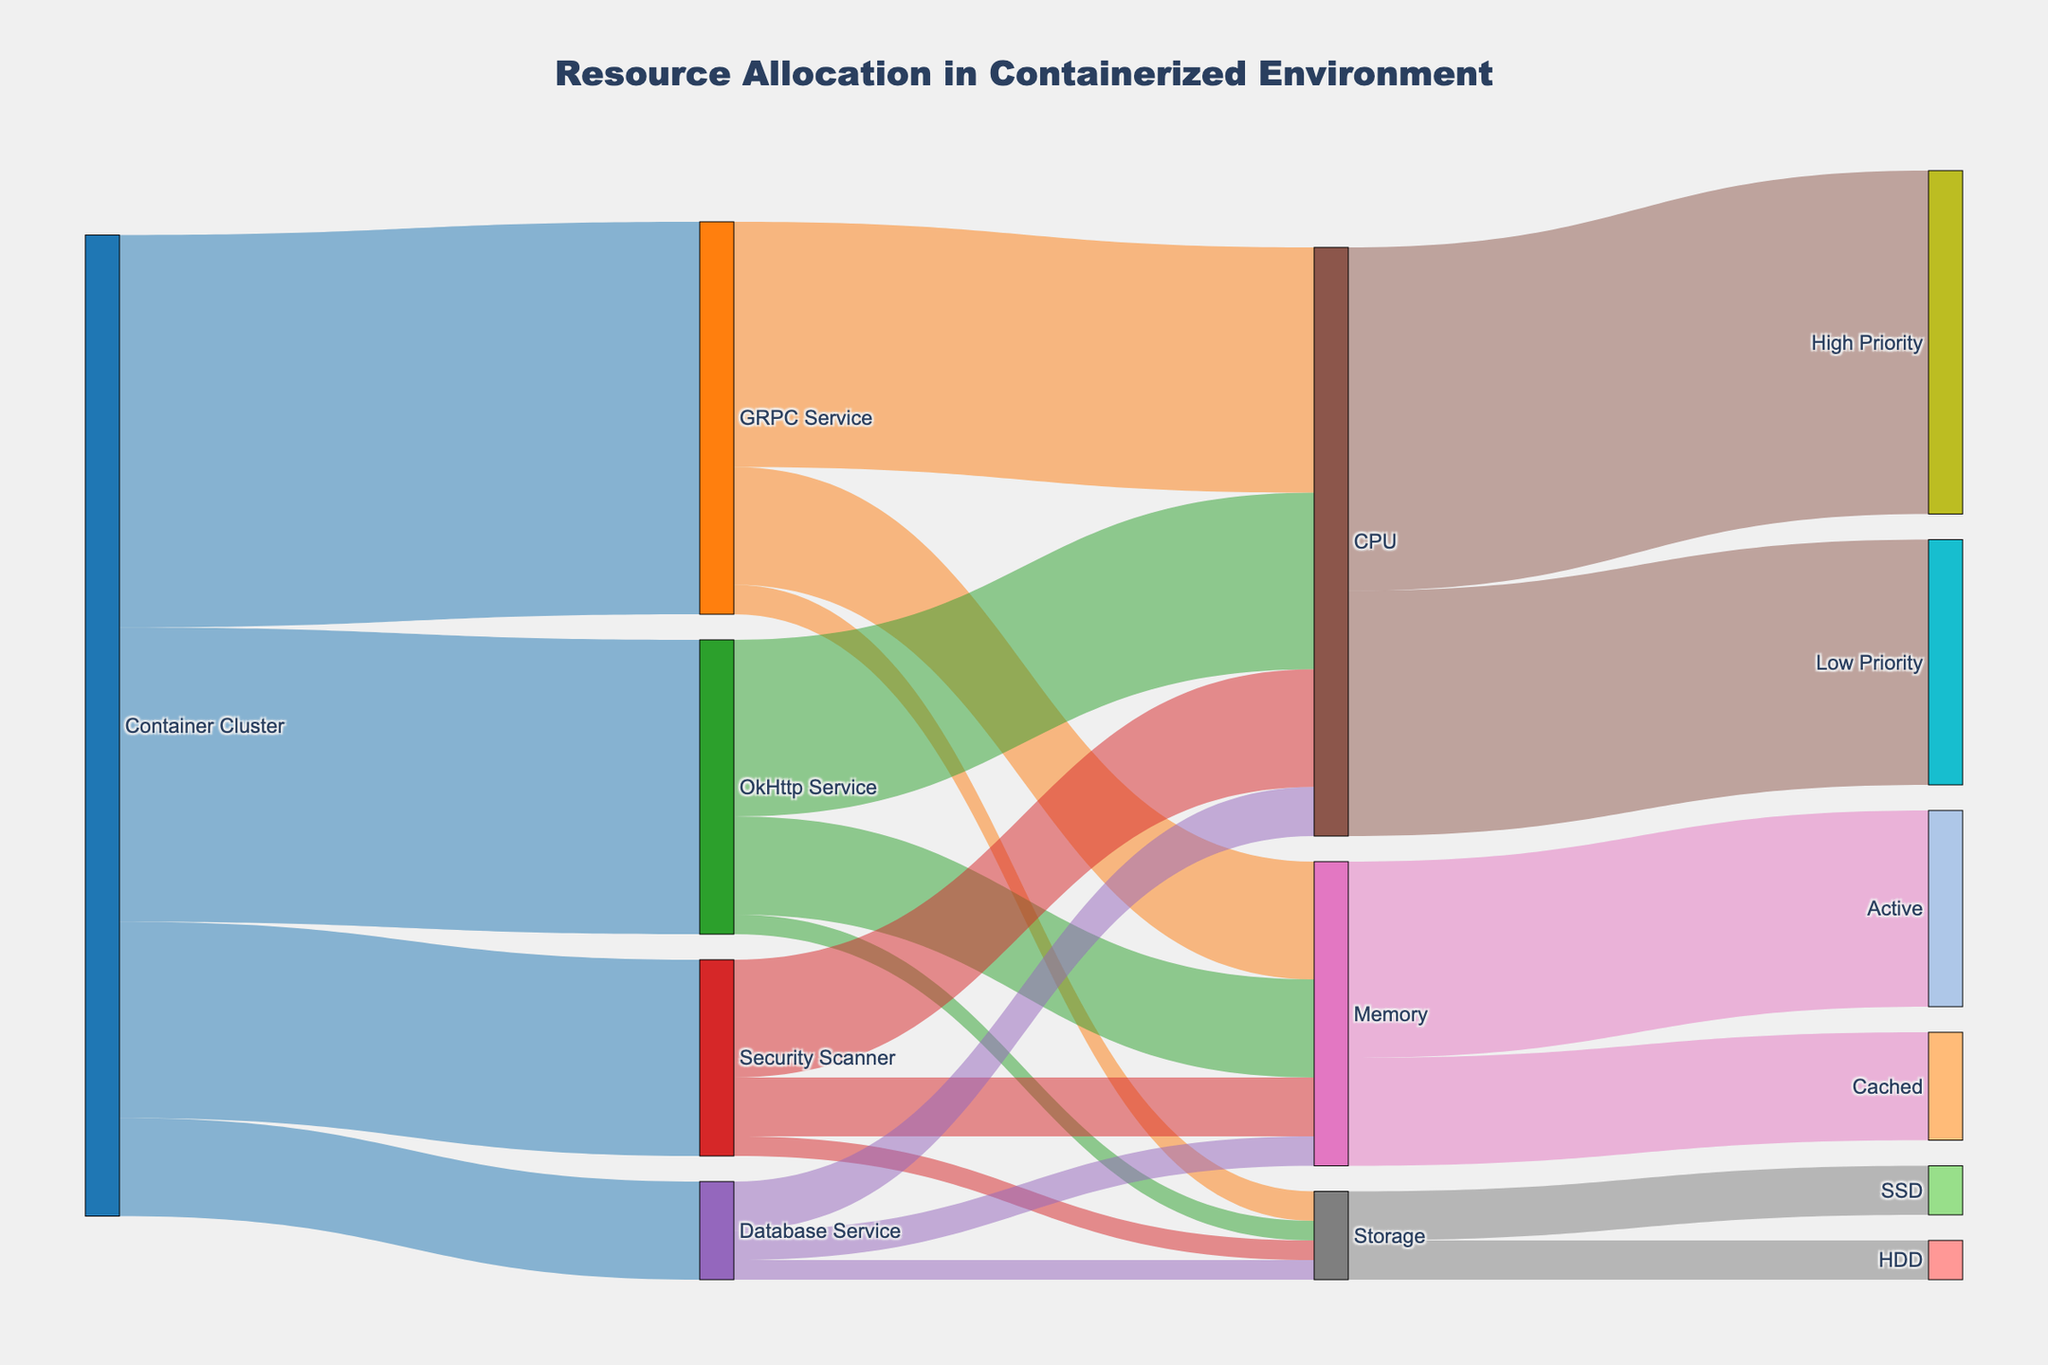How much CPU is allocated to the GRPC Service? The diagram shows the allocation from the Container Cluster to GRPC Service followed by the distribution among CPU, Memory, and Storage. The flow from GRPC Service to CPU is labeled with a value of 25.
Answer: 25 Which service has the least amount of storage allocated? The diagram shows the storage allocation from each service with values. The GRPC Service has 3, OkHttp Service has 2, Security Scanner has 2, and Database Service has 2. The smallest values are for OkHttp Service, Security Scanner, and Database Service at 2 each.
Answer: OkHttp Service, Security Scanner, Database Service What is the total CPU allocation from the Container Cluster? The diagram shows flows from the Container Cluster to different services and then further breakdowns to resources. Each service's CPU allocations are 25 for GRPC Service, 18 for OkHttp Service, 12 for Security Scanner, and 5 for Database Service. Adding these gives 25 + 18 + 12 + 5 = 60.
Answer: 60 How does memory allocation for active processes compare to cached memory? The diagram shows memory split into Active and Cached. Active has a value of 20 and Cached has a value of 11. Therefore, Active memory allocation is higher than Cached.
Answer: Active memory is higher What priority of CPU usage receives more allocation? The diagram shows CPU split into High Priority and Low Priority. High Priority receives 35, whereas Low Priority receives 25. Thus, High Priority receives more allocation.
Answer: High Priority Which resource type (CPU, Memory, or Storage) has the highest allocation in the GRPC Service? Comparing the values allocated to CPU (25), Memory (12), and Storage (3) for the GRPC Service, the highest is the CPU with a value of 25.
Answer: CPU How much memory is allocated to the Security Scanner service? From the diagram, the memory allocated to the Security Scanner is labeled with a value of 6.
Answer: 6 Compare the total storage allocation for OkHttp Service and Security Scanner. The diagram shows storage allocations of 2 for OkHttp Service and 2 for Security Scanner. Therefore, both have the same allocation of storage.
Answer: Same allocation What is the total memory allocated across all services? The memory allocations are 12 for GRPC Service, 10 for OkHttp Service, 6 for Security Scanner, and 3 for Database Service. Summing these gives 12 + 10 + 6 + 3 = 31.
Answer: 31 Which service has the highest combined allocation of all resources (CPU, Memory, Storage)? The sums are GRPC Service (25 + 12 + 3 = 40), OkHttp Service (18 + 10 + 2 = 30), Security Scanner (12 + 6 + 2 = 20), Database Service (5 + 3 + 2 = 10). The GRPC Service has the highest total of 40.
Answer: GRPC Service 